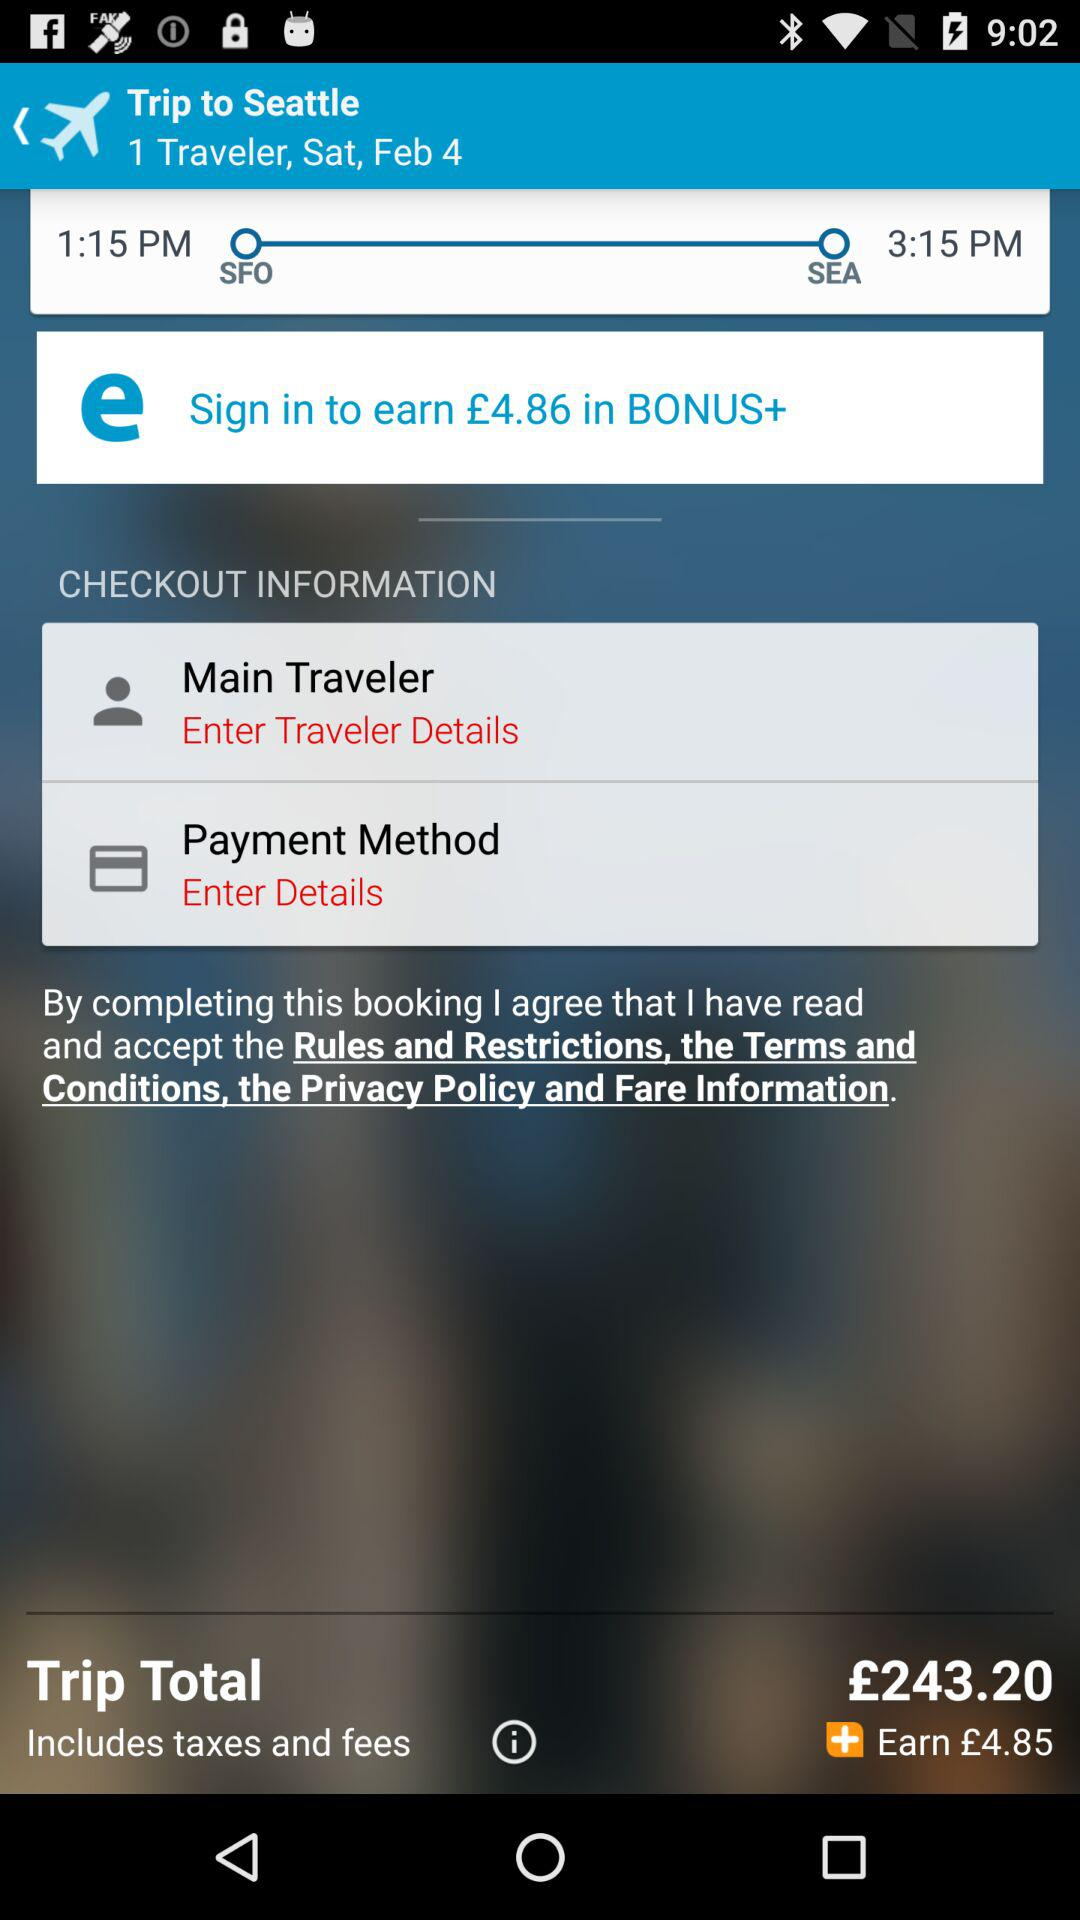What do we need to do to get a 4.86 euro bonus? You need to sign in to get the 4.86 euro bonus. 